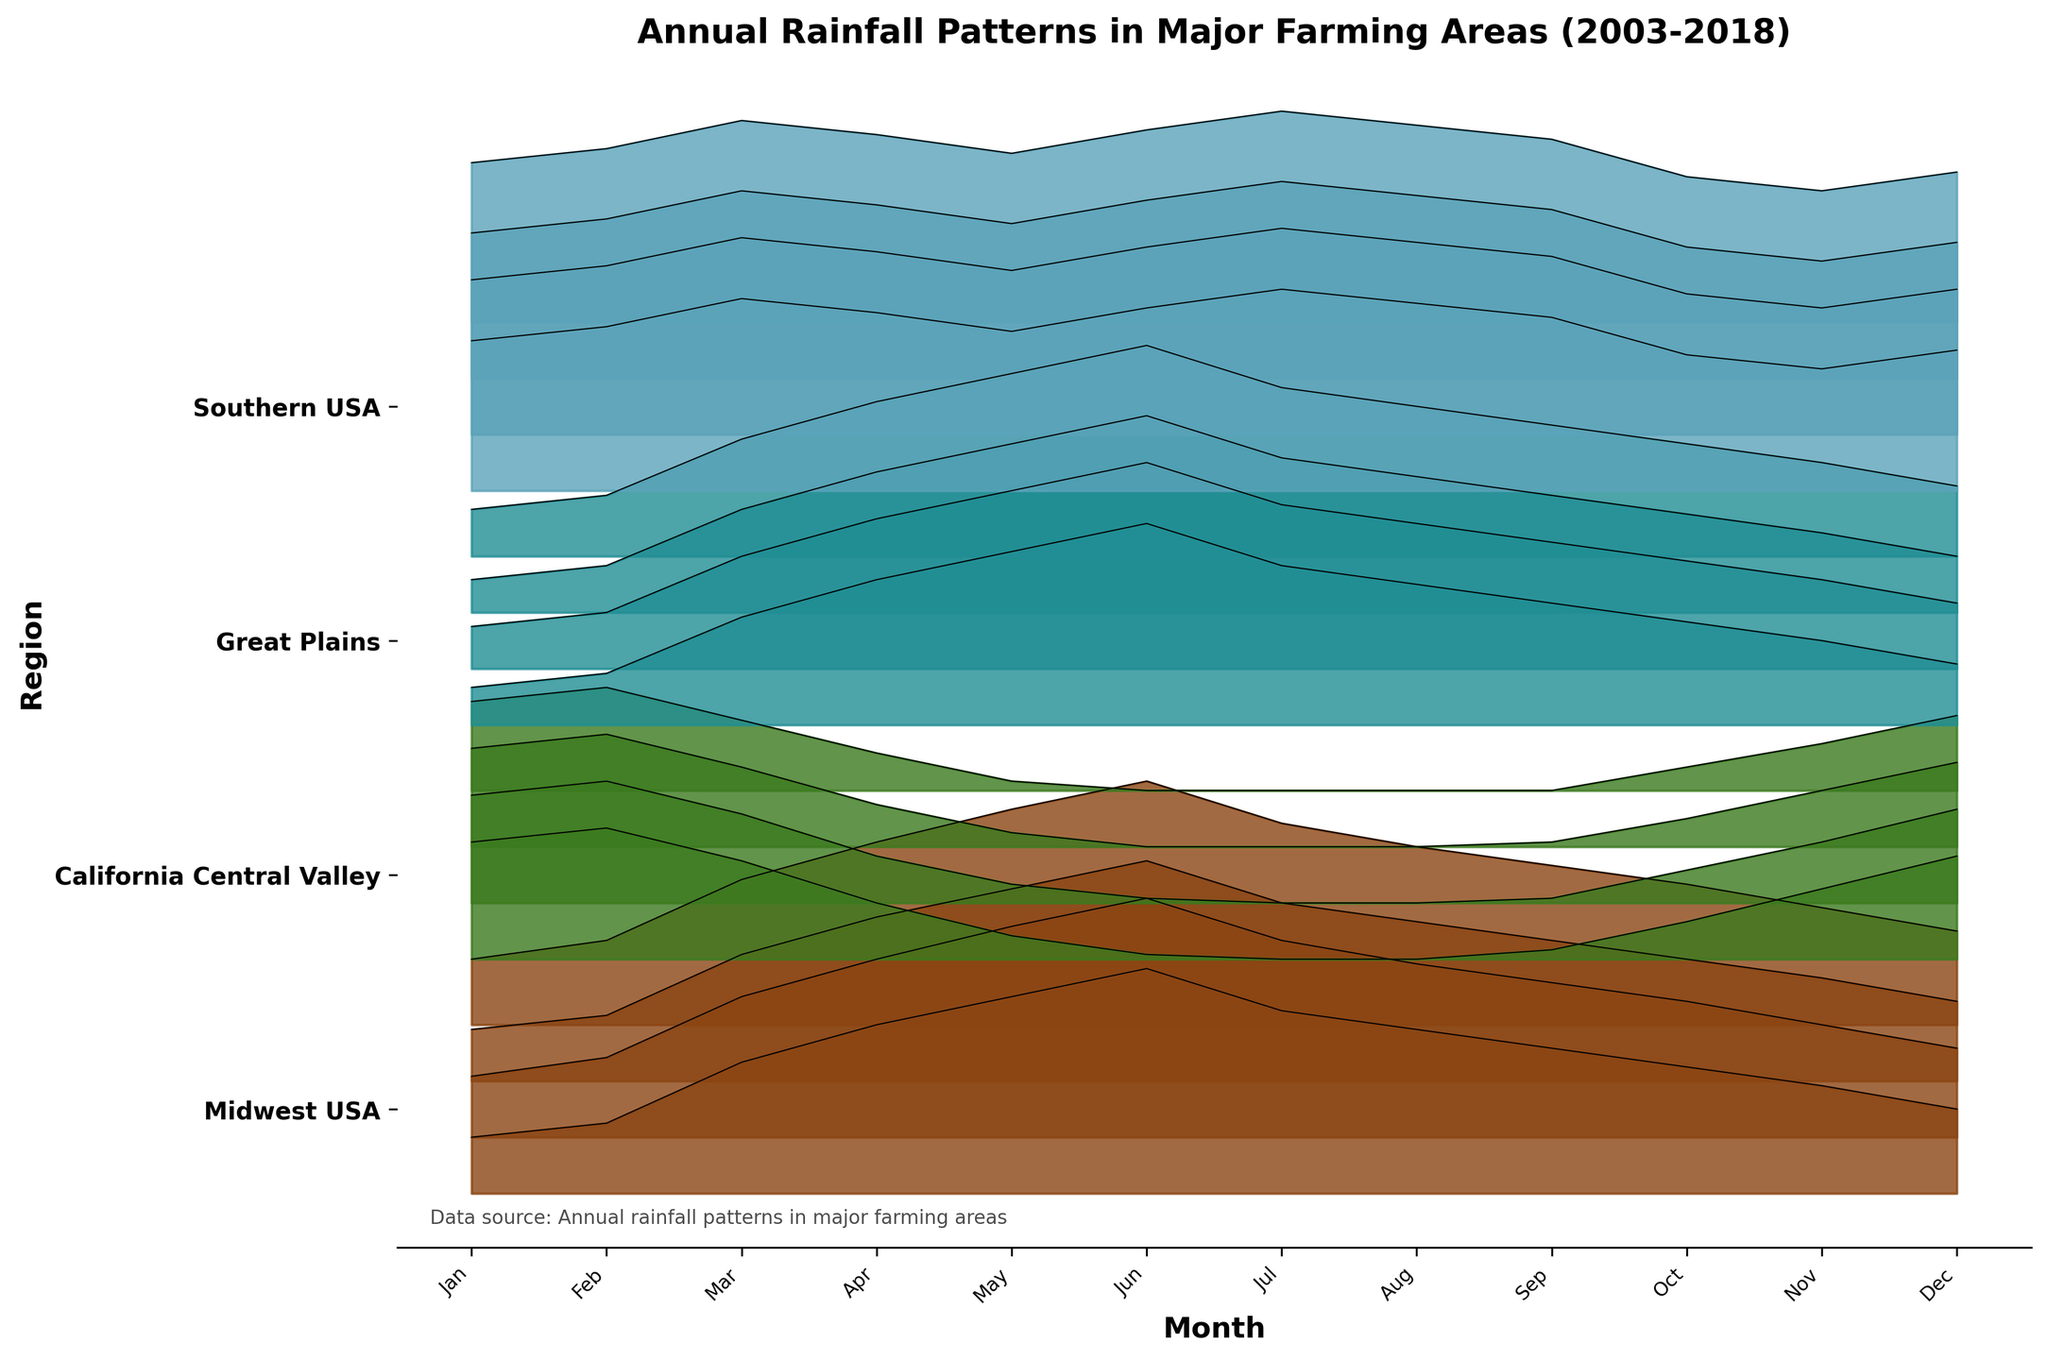What is the trend in annual rainfall for the Midwest USA region from 2003 to 2018? To determine the trend, look at the rainfall values in all 12 months for the years 2003, 2008, 2013, and 2018. Notice that the levels generally increase across these years.
Answer: Increasing Which region had the lowest rainfall in the month of July in the most recent year shown? To identify the region with the lowest rainfall in July, refer to the data for July 2018. The values are Midwest USA (4.3), California Central Valley (0.0), Great Plains (3.6), Southern USA (4.5). The lowest is in California Central Valley with 0.0.
Answer: California Central Valley Is there a noticeable difference in the rainfall pattern between the Southern USA and Great Plains regions for the month of June over the years? To find the difference, compare June rainfall values for both regions across all years. The Southern USA values (3.9, 4.0, 3.8, 4.1) are relatively stable compared to the Great Plains (4.3, 4.4, 4.2, 4.5) where fluctuations are minimal but slightly higher. Patterns are similar but Great Plains show slightly higher values.
Answer: Yes, Great Plains has slightly higher June rainfall What was the average rainfall for the California Central Valley in October for all shown years? To get the average, sum up the October values for California Central Valley and divide by the number of years: (0.8 + 0.7 + 0.6 + 0.5)/4 = 2.6/4.
Answer: 0.65 inches How does the average annual rainfall in the Southern USA compare to that of the Great Plains? First, sum annual monthly rainfall for both regions in each year and then find the averages. Summed values for Southern USA (39.5, 40.5, 38.4, 43.7) and Great Plains (30.6, 31.8, 31.4, 34.4). Averages are Southern USA: (39.5 + 40.5 + 38.4 + 43.7)/4 = 40.53, Great Plains: (30.6 + 31.8 + 31.4 + 34.4)/4 = 32.05. Compare these two averages.
Answer: Southern USA has higher average annual rainfall Which region shows the most significant seasonal variation? Assess the seasonal variation by looking at the difference between maximum and minimum monthly rainfall for each region. The California Central Valley shows the most significant variation with values ranging from almost 0 in July to up to 2.8 in February.
Answer: California Central Valley In which year did the Midwest USA experience the highest rainfall for January? Check the January values for Midwest USA across all years: January 2003 (1.2), 2008 (1.3), 2013 (1.1), 2018 (1.4). The highest value is in 2018.
Answer: 2018 Describe how the trend in rainfall for Southern USA in September compares between 2003 and 2018. Comparing the values for September in both years shows that the values increase: September 2003 (3.7) and 2018 (3.9). This indicates an increasing trend in rainfall in September for the Southern USA.
Answer: Increasing trend 